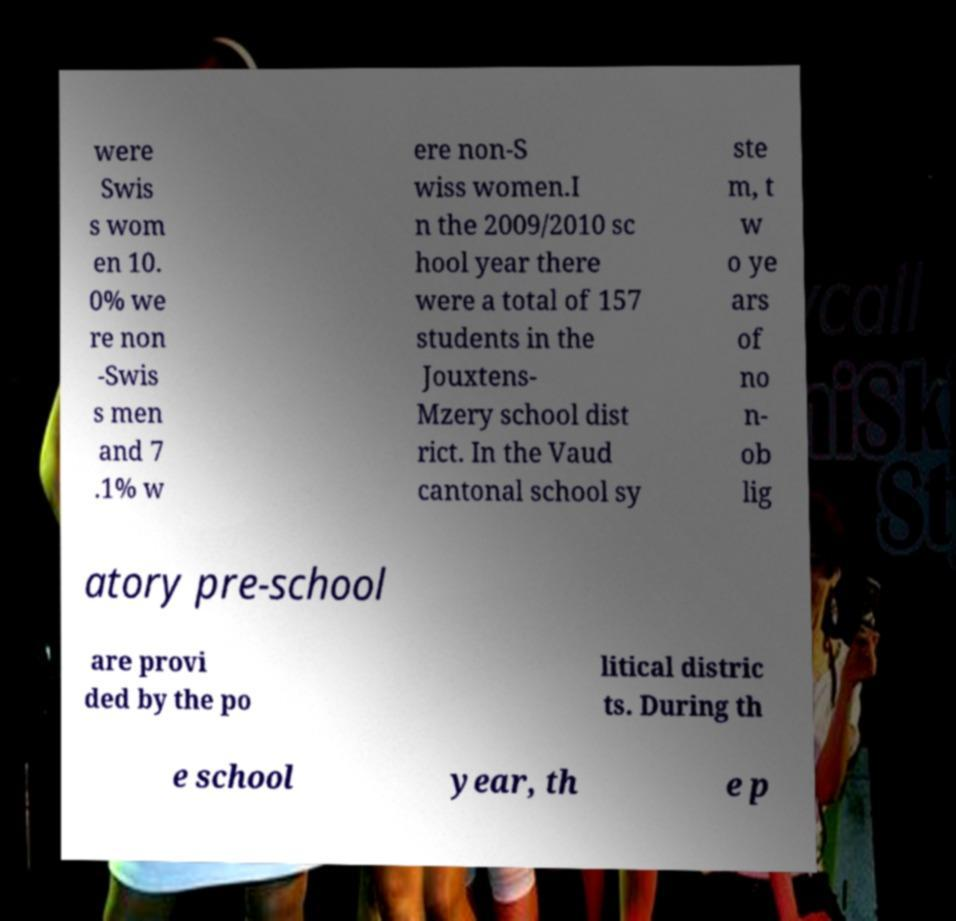Could you extract and type out the text from this image? were Swis s wom en 10. 0% we re non -Swis s men and 7 .1% w ere non-S wiss women.I n the 2009/2010 sc hool year there were a total of 157 students in the Jouxtens- Mzery school dist rict. In the Vaud cantonal school sy ste m, t w o ye ars of no n- ob lig atory pre-school are provi ded by the po litical distric ts. During th e school year, th e p 